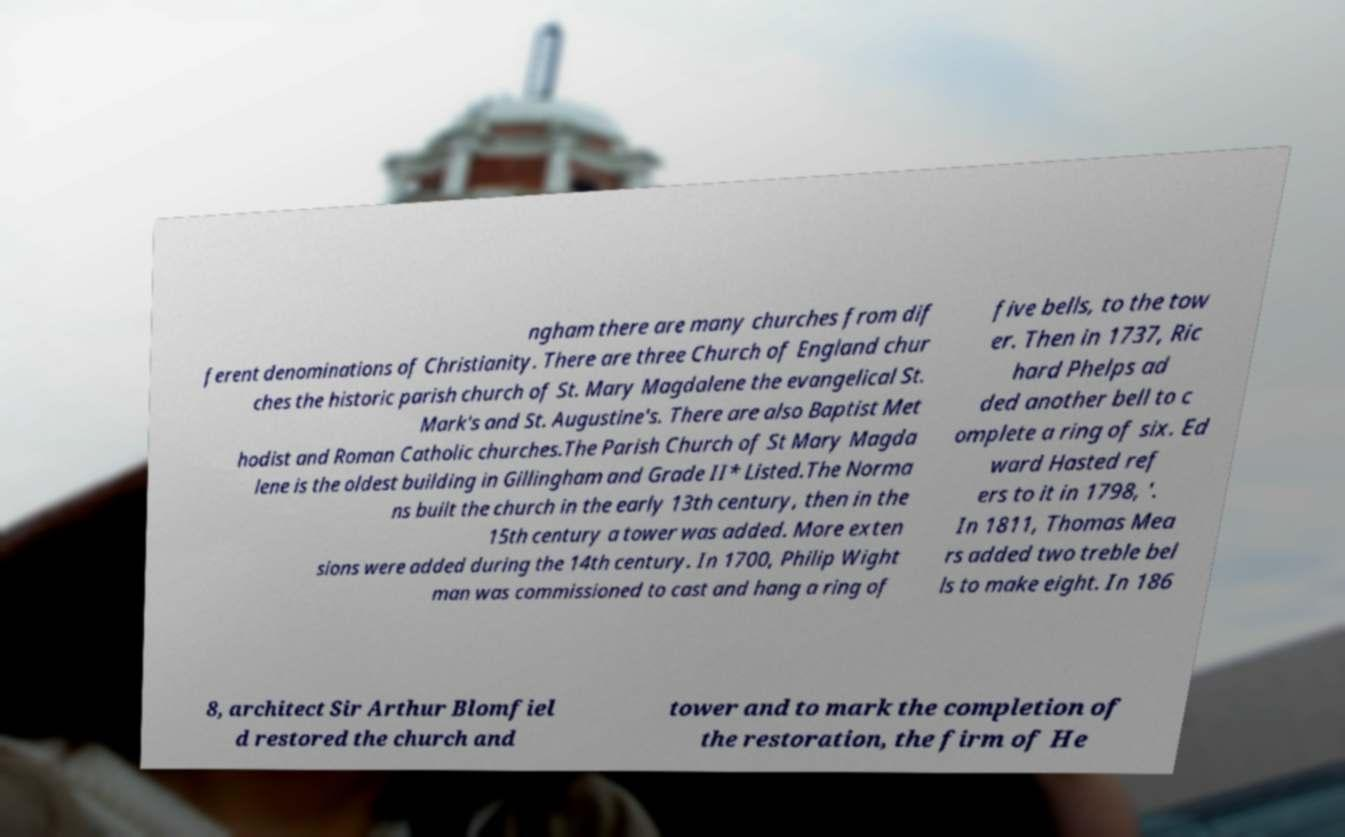Could you assist in decoding the text presented in this image and type it out clearly? ngham there are many churches from dif ferent denominations of Christianity. There are three Church of England chur ches the historic parish church of St. Mary Magdalene the evangelical St. Mark's and St. Augustine's. There are also Baptist Met hodist and Roman Catholic churches.The Parish Church of St Mary Magda lene is the oldest building in Gillingham and Grade II* Listed.The Norma ns built the church in the early 13th century, then in the 15th century a tower was added. More exten sions were added during the 14th century. In 1700, Philip Wight man was commissioned to cast and hang a ring of five bells, to the tow er. Then in 1737, Ric hard Phelps ad ded another bell to c omplete a ring of six. Ed ward Hasted ref ers to it in 1798, '. In 1811, Thomas Mea rs added two treble bel ls to make eight. In 186 8, architect Sir Arthur Blomfiel d restored the church and tower and to mark the completion of the restoration, the firm of He 